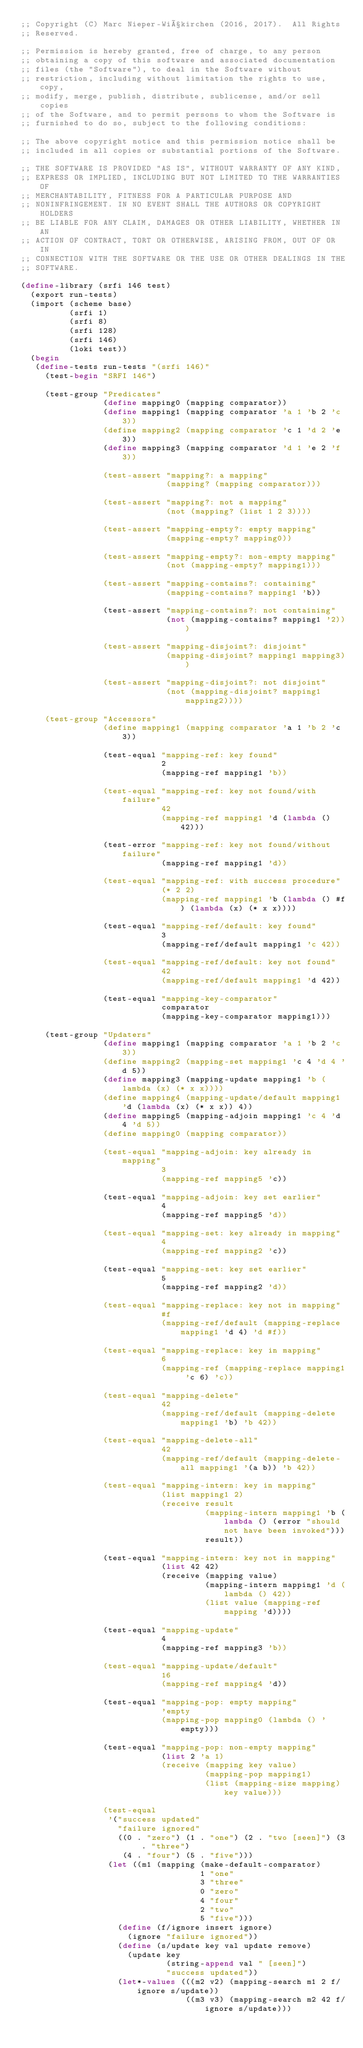Convert code to text. <code><loc_0><loc_0><loc_500><loc_500><_Scheme_>;; Copyright (C) Marc Nieper-Wißkirchen (2016, 2017).  All Rights
;; Reserved.

;; Permission is hereby granted, free of charge, to any person
;; obtaining a copy of this software and associated documentation
;; files (the "Software"), to deal in the Software without
;; restriction, including without limitation the rights to use, copy,
;; modify, merge, publish, distribute, sublicense, and/or sell copies
;; of the Software, and to permit persons to whom the Software is
;; furnished to do so, subject to the following conditions:

;; The above copyright notice and this permission notice shall be
;; included in all copies or substantial portions of the Software.

;; THE SOFTWARE IS PROVIDED "AS IS", WITHOUT WARRANTY OF ANY KIND,
;; EXPRESS OR IMPLIED, INCLUDING BUT NOT LIMITED TO THE WARRANTIES OF
;; MERCHANTABILITY, FITNESS FOR A PARTICULAR PURPOSE AND
;; NONINFRINGEMENT. IN NO EVENT SHALL THE AUTHORS OR COPYRIGHT HOLDERS
;; BE LIABLE FOR ANY CLAIM, DAMAGES OR OTHER LIABILITY, WHETHER IN AN
;; ACTION OF CONTRACT, TORT OR OTHERWISE, ARISING FROM, OUT OF OR IN
;; CONNECTION WITH THE SOFTWARE OR THE USE OR OTHER DEALINGS IN THE
;; SOFTWARE.

(define-library (srfi 146 test)
  (export run-tests)
  (import (scheme base)
          (srfi 1)
          (srfi 8)
          (srfi 128)
          (srfi 146)
          (loki test))
  (begin
   (define-tests run-tests "(srfi 146)"
     (test-begin "SRFI 146")
     
     (test-group "Predicates"
                 (define mapping0 (mapping comparator))
                 (define mapping1 (mapping comparator 'a 1 'b 2 'c 3))
                 (define mapping2 (mapping comparator 'c 1 'd 2 'e 3))
                 (define mapping3 (mapping comparator 'd 1 'e 2 'f 3))
                 
                 (test-assert "mapping?: a mapping"
                              (mapping? (mapping comparator)))
                 
                 (test-assert "mapping?: not a mapping"
                              (not (mapping? (list 1 2 3))))
                 
                 (test-assert "mapping-empty?: empty mapping"
                              (mapping-empty? mapping0))
                 
                 (test-assert "mapping-empty?: non-empty mapping"
                              (not (mapping-empty? mapping1)))
                 
                 (test-assert "mapping-contains?: containing"
                              (mapping-contains? mapping1 'b))
                 
                 (test-assert "mapping-contains?: not containing"
                              (not (mapping-contains? mapping1 '2)))
                 
                 (test-assert "mapping-disjoint?: disjoint"
                              (mapping-disjoint? mapping1 mapping3))
                 
                 (test-assert "mapping-disjoint?: not disjoint"
                              (not (mapping-disjoint? mapping1 mapping2))))
     
     (test-group "Accessors"
                 (define mapping1 (mapping comparator 'a 1 'b 2 'c 3))
                 
                 (test-equal "mapping-ref: key found"
                             2
                             (mapping-ref mapping1 'b))
                 
                 (test-equal "mapping-ref: key not found/with failure"
                             42
                             (mapping-ref mapping1 'd (lambda () 42)))
                 
                 (test-error "mapping-ref: key not found/without failure"
                             (mapping-ref mapping1 'd))
                 
                 (test-equal "mapping-ref: with success procedure"
                             (* 2 2)
                             (mapping-ref mapping1 'b (lambda () #f) (lambda (x) (* x x))))
                 
                 (test-equal "mapping-ref/default: key found"
                             3
                             (mapping-ref/default mapping1 'c 42))
                 
                 (test-equal "mapping-ref/default: key not found"
                             42
                             (mapping-ref/default mapping1 'd 42))
                 
                 (test-equal "mapping-key-comparator"
                             comparator
                             (mapping-key-comparator mapping1)))
     
     (test-group "Updaters"
                 (define mapping1 (mapping comparator 'a 1 'b 2 'c 3))
                 (define mapping2 (mapping-set mapping1 'c 4 'd 4 'd 5))
                 (define mapping3 (mapping-update mapping1 'b (lambda (x) (* x x))))
                 (define mapping4 (mapping-update/default mapping1 'd (lambda (x) (* x x)) 4))
                 (define mapping5 (mapping-adjoin mapping1 'c 4 'd 4 'd 5))
                 (define mapping0 (mapping comparator))
                 
                 (test-equal "mapping-adjoin: key already in mapping"
                             3
                             (mapping-ref mapping5 'c))
                 
                 (test-equal "mapping-adjoin: key set earlier"
                             4
                             (mapping-ref mapping5 'd))
                 
                 (test-equal "mapping-set: key already in mapping"
                             4
                             (mapping-ref mapping2 'c))
                 
                 (test-equal "mapping-set: key set earlier"
                             5
                             (mapping-ref mapping2 'd))
                 
                 (test-equal "mapping-replace: key not in mapping"
                             #f
                             (mapping-ref/default (mapping-replace mapping1 'd 4) 'd #f))
                 
                 (test-equal "mapping-replace: key in mapping"
                             6
                             (mapping-ref (mapping-replace mapping1 'c 6) 'c))
                 
                 (test-equal "mapping-delete"
                             42
                             (mapping-ref/default (mapping-delete mapping1 'b) 'b 42))
                 
                 (test-equal "mapping-delete-all"
                             42
                             (mapping-ref/default (mapping-delete-all mapping1 '(a b)) 'b 42))
                 
                 (test-equal "mapping-intern: key in mapping"
                             (list mapping1 2)
                             (receive result
                                      (mapping-intern mapping1 'b (lambda () (error "should not have been invoked")))
                                      result))
                 
                 (test-equal "mapping-intern: key not in mapping"
                             (list 42 42)
                             (receive (mapping value)
                                      (mapping-intern mapping1 'd (lambda () 42))
                                      (list value (mapping-ref mapping 'd))))
                 
                 (test-equal "mapping-update"
                             4
                             (mapping-ref mapping3 'b))
                 
                 (test-equal "mapping-update/default"
                             16
                             (mapping-ref mapping4 'd))
                 
                 (test-equal "mapping-pop: empty mapping"
                             'empty
                             (mapping-pop mapping0 (lambda () 'empty)))
                 
                 (test-equal "mapping-pop: non-empty mapping"
                             (list 2 'a 1)
                             (receive (mapping key value)
                                      (mapping-pop mapping1)
                                      (list (mapping-size mapping) key value)))
                 
                 (test-equal
                  '("success updated"
                    "failure ignored"
                    ((0 . "zero") (1 . "one") (2 . "two [seen]") (3 . "three")
                     (4 . "four") (5 . "five")))
                  (let ((m1 (mapping (make-default-comparator)
                                     1 "one"
                                     3 "three"
                                     0 "zero"
                                     4 "four"
                                     2 "two"
                                     5 "five")))
                    (define (f/ignore insert ignore)
                      (ignore "failure ignored"))
                    (define (s/update key val update remove)
                      (update key
                              (string-append val " [seen]")
                              "success updated"))
                    (let*-values (((m2 v2) (mapping-search m1 2 f/ignore s/update))
                                  ((m3 v3) (mapping-search m2 42 f/ignore s/update)))</code> 